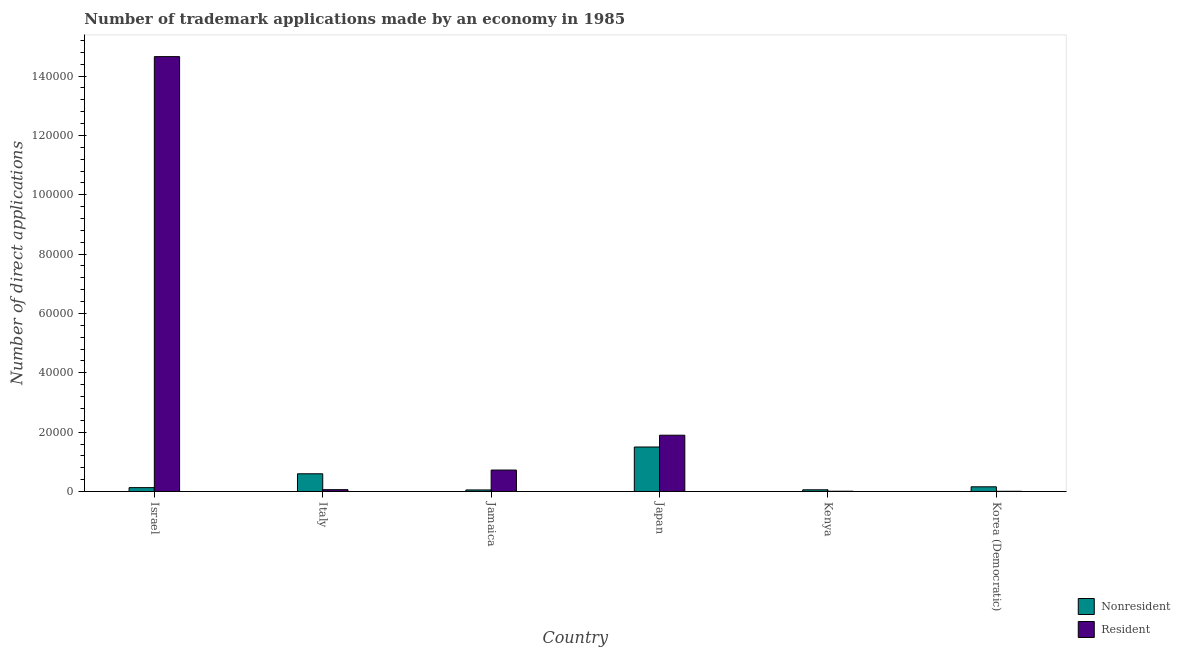How many groups of bars are there?
Your answer should be compact. 6. Are the number of bars per tick equal to the number of legend labels?
Give a very brief answer. Yes. Are the number of bars on each tick of the X-axis equal?
Keep it short and to the point. Yes. How many bars are there on the 3rd tick from the left?
Keep it short and to the point. 2. What is the label of the 5th group of bars from the left?
Provide a succinct answer. Kenya. What is the number of trademark applications made by non residents in Korea (Democratic)?
Offer a very short reply. 1576. Across all countries, what is the maximum number of trademark applications made by non residents?
Your response must be concise. 1.50e+04. Across all countries, what is the minimum number of trademark applications made by residents?
Your answer should be very brief. 60. In which country was the number of trademark applications made by non residents maximum?
Offer a very short reply. Japan. In which country was the number of trademark applications made by non residents minimum?
Keep it short and to the point. Jamaica. What is the total number of trademark applications made by non residents in the graph?
Ensure brevity in your answer.  2.49e+04. What is the difference between the number of trademark applications made by non residents in Israel and that in Kenya?
Offer a very short reply. 729. What is the difference between the number of trademark applications made by non residents in Korea (Democratic) and the number of trademark applications made by residents in Japan?
Keep it short and to the point. -1.74e+04. What is the average number of trademark applications made by non residents per country?
Ensure brevity in your answer.  4151. What is the difference between the number of trademark applications made by non residents and number of trademark applications made by residents in Japan?
Keep it short and to the point. -3973. In how many countries, is the number of trademark applications made by non residents greater than 76000 ?
Provide a short and direct response. 0. What is the ratio of the number of trademark applications made by non residents in Jamaica to that in Korea (Democratic)?
Give a very brief answer. 0.33. What is the difference between the highest and the second highest number of trademark applications made by non residents?
Make the answer very short. 9025. What is the difference between the highest and the lowest number of trademark applications made by residents?
Offer a terse response. 1.46e+05. Is the sum of the number of trademark applications made by residents in Italy and Jamaica greater than the maximum number of trademark applications made by non residents across all countries?
Provide a succinct answer. No. What does the 2nd bar from the left in Japan represents?
Provide a short and direct response. Resident. What does the 1st bar from the right in Japan represents?
Provide a succinct answer. Resident. How many countries are there in the graph?
Offer a terse response. 6. How many legend labels are there?
Your answer should be compact. 2. How are the legend labels stacked?
Give a very brief answer. Vertical. What is the title of the graph?
Keep it short and to the point. Number of trademark applications made by an economy in 1985. What is the label or title of the X-axis?
Offer a very short reply. Country. What is the label or title of the Y-axis?
Ensure brevity in your answer.  Number of direct applications. What is the Number of direct applications in Nonresident in Israel?
Your response must be concise. 1295. What is the Number of direct applications in Resident in Israel?
Keep it short and to the point. 1.47e+05. What is the Number of direct applications in Nonresident in Italy?
Offer a very short reply. 5964. What is the Number of direct applications of Resident in Italy?
Provide a succinct answer. 613. What is the Number of direct applications of Nonresident in Jamaica?
Provide a short and direct response. 516. What is the Number of direct applications in Resident in Jamaica?
Your answer should be very brief. 7220. What is the Number of direct applications of Nonresident in Japan?
Make the answer very short. 1.50e+04. What is the Number of direct applications of Resident in Japan?
Offer a terse response. 1.90e+04. What is the Number of direct applications of Nonresident in Kenya?
Your response must be concise. 566. What is the Number of direct applications in Nonresident in Korea (Democratic)?
Your answer should be very brief. 1576. Across all countries, what is the maximum Number of direct applications in Nonresident?
Your response must be concise. 1.50e+04. Across all countries, what is the maximum Number of direct applications in Resident?
Give a very brief answer. 1.47e+05. Across all countries, what is the minimum Number of direct applications in Nonresident?
Keep it short and to the point. 516. What is the total Number of direct applications in Nonresident in the graph?
Give a very brief answer. 2.49e+04. What is the total Number of direct applications in Resident in the graph?
Your response must be concise. 1.73e+05. What is the difference between the Number of direct applications in Nonresident in Israel and that in Italy?
Your answer should be compact. -4669. What is the difference between the Number of direct applications of Resident in Israel and that in Italy?
Your answer should be compact. 1.46e+05. What is the difference between the Number of direct applications of Nonresident in Israel and that in Jamaica?
Give a very brief answer. 779. What is the difference between the Number of direct applications in Resident in Israel and that in Jamaica?
Provide a short and direct response. 1.39e+05. What is the difference between the Number of direct applications in Nonresident in Israel and that in Japan?
Provide a short and direct response. -1.37e+04. What is the difference between the Number of direct applications of Resident in Israel and that in Japan?
Your answer should be very brief. 1.28e+05. What is the difference between the Number of direct applications in Nonresident in Israel and that in Kenya?
Your response must be concise. 729. What is the difference between the Number of direct applications in Resident in Israel and that in Kenya?
Keep it short and to the point. 1.46e+05. What is the difference between the Number of direct applications of Nonresident in Israel and that in Korea (Democratic)?
Your answer should be compact. -281. What is the difference between the Number of direct applications in Resident in Israel and that in Korea (Democratic)?
Your answer should be compact. 1.46e+05. What is the difference between the Number of direct applications of Nonresident in Italy and that in Jamaica?
Your answer should be compact. 5448. What is the difference between the Number of direct applications of Resident in Italy and that in Jamaica?
Ensure brevity in your answer.  -6607. What is the difference between the Number of direct applications in Nonresident in Italy and that in Japan?
Provide a short and direct response. -9025. What is the difference between the Number of direct applications in Resident in Italy and that in Japan?
Provide a succinct answer. -1.83e+04. What is the difference between the Number of direct applications of Nonresident in Italy and that in Kenya?
Keep it short and to the point. 5398. What is the difference between the Number of direct applications of Resident in Italy and that in Kenya?
Provide a short and direct response. 533. What is the difference between the Number of direct applications in Nonresident in Italy and that in Korea (Democratic)?
Your answer should be very brief. 4388. What is the difference between the Number of direct applications of Resident in Italy and that in Korea (Democratic)?
Keep it short and to the point. 553. What is the difference between the Number of direct applications in Nonresident in Jamaica and that in Japan?
Offer a very short reply. -1.45e+04. What is the difference between the Number of direct applications of Resident in Jamaica and that in Japan?
Provide a succinct answer. -1.17e+04. What is the difference between the Number of direct applications in Resident in Jamaica and that in Kenya?
Provide a short and direct response. 7140. What is the difference between the Number of direct applications of Nonresident in Jamaica and that in Korea (Democratic)?
Offer a terse response. -1060. What is the difference between the Number of direct applications in Resident in Jamaica and that in Korea (Democratic)?
Provide a succinct answer. 7160. What is the difference between the Number of direct applications in Nonresident in Japan and that in Kenya?
Ensure brevity in your answer.  1.44e+04. What is the difference between the Number of direct applications of Resident in Japan and that in Kenya?
Your answer should be very brief. 1.89e+04. What is the difference between the Number of direct applications in Nonresident in Japan and that in Korea (Democratic)?
Provide a short and direct response. 1.34e+04. What is the difference between the Number of direct applications in Resident in Japan and that in Korea (Democratic)?
Ensure brevity in your answer.  1.89e+04. What is the difference between the Number of direct applications in Nonresident in Kenya and that in Korea (Democratic)?
Ensure brevity in your answer.  -1010. What is the difference between the Number of direct applications in Nonresident in Israel and the Number of direct applications in Resident in Italy?
Give a very brief answer. 682. What is the difference between the Number of direct applications of Nonresident in Israel and the Number of direct applications of Resident in Jamaica?
Ensure brevity in your answer.  -5925. What is the difference between the Number of direct applications of Nonresident in Israel and the Number of direct applications of Resident in Japan?
Provide a short and direct response. -1.77e+04. What is the difference between the Number of direct applications of Nonresident in Israel and the Number of direct applications of Resident in Kenya?
Provide a succinct answer. 1215. What is the difference between the Number of direct applications of Nonresident in Israel and the Number of direct applications of Resident in Korea (Democratic)?
Your answer should be compact. 1235. What is the difference between the Number of direct applications in Nonresident in Italy and the Number of direct applications in Resident in Jamaica?
Keep it short and to the point. -1256. What is the difference between the Number of direct applications in Nonresident in Italy and the Number of direct applications in Resident in Japan?
Keep it short and to the point. -1.30e+04. What is the difference between the Number of direct applications in Nonresident in Italy and the Number of direct applications in Resident in Kenya?
Offer a very short reply. 5884. What is the difference between the Number of direct applications of Nonresident in Italy and the Number of direct applications of Resident in Korea (Democratic)?
Your answer should be compact. 5904. What is the difference between the Number of direct applications in Nonresident in Jamaica and the Number of direct applications in Resident in Japan?
Provide a succinct answer. -1.84e+04. What is the difference between the Number of direct applications in Nonresident in Jamaica and the Number of direct applications in Resident in Kenya?
Offer a terse response. 436. What is the difference between the Number of direct applications of Nonresident in Jamaica and the Number of direct applications of Resident in Korea (Democratic)?
Your response must be concise. 456. What is the difference between the Number of direct applications of Nonresident in Japan and the Number of direct applications of Resident in Kenya?
Ensure brevity in your answer.  1.49e+04. What is the difference between the Number of direct applications of Nonresident in Japan and the Number of direct applications of Resident in Korea (Democratic)?
Your response must be concise. 1.49e+04. What is the difference between the Number of direct applications of Nonresident in Kenya and the Number of direct applications of Resident in Korea (Democratic)?
Your answer should be very brief. 506. What is the average Number of direct applications in Nonresident per country?
Make the answer very short. 4151. What is the average Number of direct applications in Resident per country?
Provide a short and direct response. 2.89e+04. What is the difference between the Number of direct applications of Nonresident and Number of direct applications of Resident in Israel?
Provide a succinct answer. -1.45e+05. What is the difference between the Number of direct applications in Nonresident and Number of direct applications in Resident in Italy?
Provide a short and direct response. 5351. What is the difference between the Number of direct applications in Nonresident and Number of direct applications in Resident in Jamaica?
Provide a short and direct response. -6704. What is the difference between the Number of direct applications of Nonresident and Number of direct applications of Resident in Japan?
Offer a terse response. -3973. What is the difference between the Number of direct applications in Nonresident and Number of direct applications in Resident in Kenya?
Keep it short and to the point. 486. What is the difference between the Number of direct applications of Nonresident and Number of direct applications of Resident in Korea (Democratic)?
Your answer should be compact. 1516. What is the ratio of the Number of direct applications in Nonresident in Israel to that in Italy?
Offer a very short reply. 0.22. What is the ratio of the Number of direct applications of Resident in Israel to that in Italy?
Your answer should be compact. 239.08. What is the ratio of the Number of direct applications in Nonresident in Israel to that in Jamaica?
Ensure brevity in your answer.  2.51. What is the ratio of the Number of direct applications of Resident in Israel to that in Jamaica?
Provide a short and direct response. 20.3. What is the ratio of the Number of direct applications of Nonresident in Israel to that in Japan?
Keep it short and to the point. 0.09. What is the ratio of the Number of direct applications in Resident in Israel to that in Japan?
Provide a succinct answer. 7.73. What is the ratio of the Number of direct applications of Nonresident in Israel to that in Kenya?
Give a very brief answer. 2.29. What is the ratio of the Number of direct applications in Resident in Israel to that in Kenya?
Provide a succinct answer. 1831.96. What is the ratio of the Number of direct applications of Nonresident in Israel to that in Korea (Democratic)?
Your answer should be compact. 0.82. What is the ratio of the Number of direct applications of Resident in Israel to that in Korea (Democratic)?
Your answer should be very brief. 2442.62. What is the ratio of the Number of direct applications of Nonresident in Italy to that in Jamaica?
Provide a short and direct response. 11.56. What is the ratio of the Number of direct applications of Resident in Italy to that in Jamaica?
Your answer should be compact. 0.08. What is the ratio of the Number of direct applications in Nonresident in Italy to that in Japan?
Provide a short and direct response. 0.4. What is the ratio of the Number of direct applications of Resident in Italy to that in Japan?
Give a very brief answer. 0.03. What is the ratio of the Number of direct applications of Nonresident in Italy to that in Kenya?
Make the answer very short. 10.54. What is the ratio of the Number of direct applications in Resident in Italy to that in Kenya?
Offer a terse response. 7.66. What is the ratio of the Number of direct applications of Nonresident in Italy to that in Korea (Democratic)?
Ensure brevity in your answer.  3.78. What is the ratio of the Number of direct applications of Resident in Italy to that in Korea (Democratic)?
Offer a very short reply. 10.22. What is the ratio of the Number of direct applications in Nonresident in Jamaica to that in Japan?
Your response must be concise. 0.03. What is the ratio of the Number of direct applications in Resident in Jamaica to that in Japan?
Offer a very short reply. 0.38. What is the ratio of the Number of direct applications in Nonresident in Jamaica to that in Kenya?
Offer a very short reply. 0.91. What is the ratio of the Number of direct applications of Resident in Jamaica to that in Kenya?
Offer a very short reply. 90.25. What is the ratio of the Number of direct applications of Nonresident in Jamaica to that in Korea (Democratic)?
Your response must be concise. 0.33. What is the ratio of the Number of direct applications of Resident in Jamaica to that in Korea (Democratic)?
Make the answer very short. 120.33. What is the ratio of the Number of direct applications in Nonresident in Japan to that in Kenya?
Your response must be concise. 26.48. What is the ratio of the Number of direct applications of Resident in Japan to that in Kenya?
Your answer should be compact. 237.03. What is the ratio of the Number of direct applications in Nonresident in Japan to that in Korea (Democratic)?
Give a very brief answer. 9.51. What is the ratio of the Number of direct applications in Resident in Japan to that in Korea (Democratic)?
Your response must be concise. 316.03. What is the ratio of the Number of direct applications in Nonresident in Kenya to that in Korea (Democratic)?
Your response must be concise. 0.36. What is the difference between the highest and the second highest Number of direct applications in Nonresident?
Provide a short and direct response. 9025. What is the difference between the highest and the second highest Number of direct applications in Resident?
Ensure brevity in your answer.  1.28e+05. What is the difference between the highest and the lowest Number of direct applications of Nonresident?
Provide a succinct answer. 1.45e+04. What is the difference between the highest and the lowest Number of direct applications in Resident?
Provide a succinct answer. 1.46e+05. 